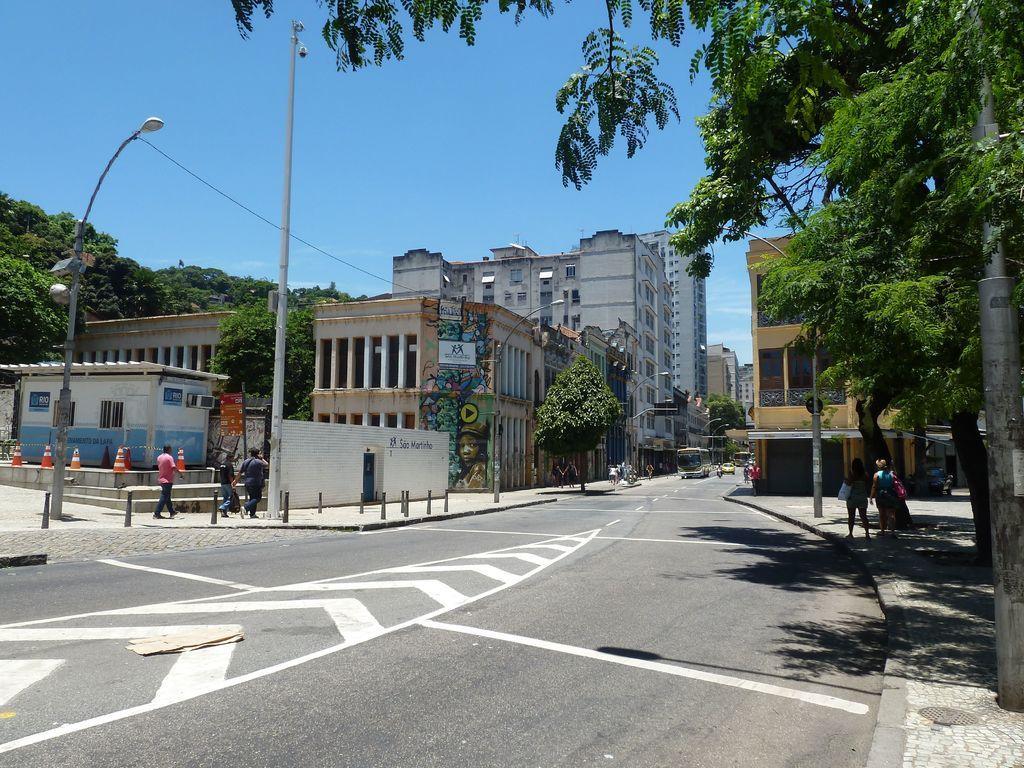Please provide a concise description of this image. In this picture I can see buildings, street lights, poles and people. Here I can see vehicles on the road. In the background I can see trees and the sky. 